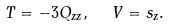Convert formula to latex. <formula><loc_0><loc_0><loc_500><loc_500>T = - 3 Q _ { z z } , \ \ V = s _ { z } .</formula> 